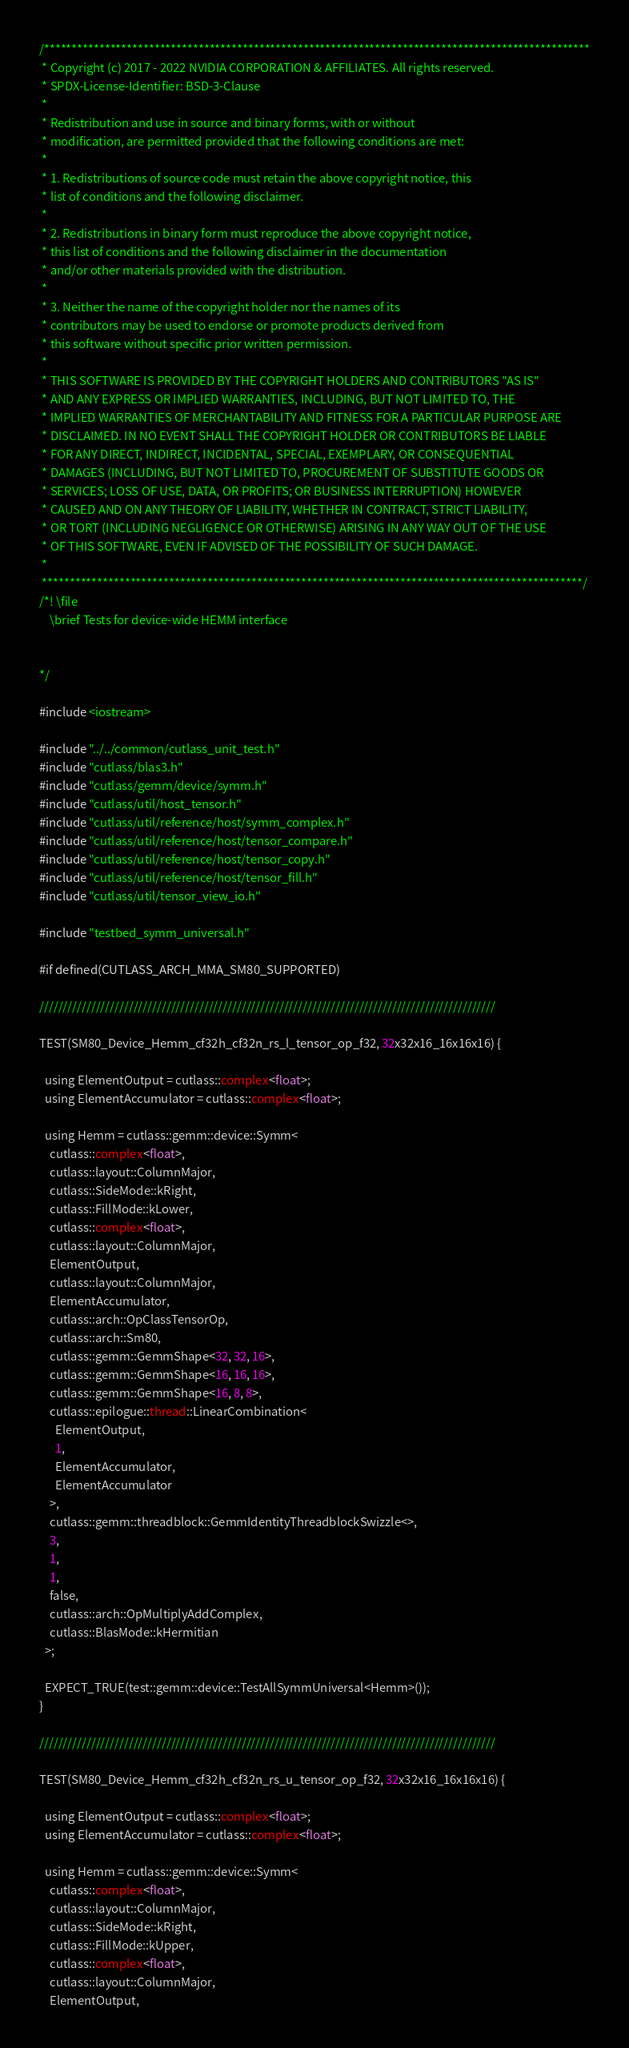Convert code to text. <code><loc_0><loc_0><loc_500><loc_500><_Cuda_>/***************************************************************************************************
 * Copyright (c) 2017 - 2022 NVIDIA CORPORATION & AFFILIATES. All rights reserved.
 * SPDX-License-Identifier: BSD-3-Clause
 *
 * Redistribution and use in source and binary forms, with or without
 * modification, are permitted provided that the following conditions are met:
 *
 * 1. Redistributions of source code must retain the above copyright notice, this
 * list of conditions and the following disclaimer.
 *
 * 2. Redistributions in binary form must reproduce the above copyright notice,
 * this list of conditions and the following disclaimer in the documentation
 * and/or other materials provided with the distribution.
 *
 * 3. Neither the name of the copyright holder nor the names of its
 * contributors may be used to endorse or promote products derived from
 * this software without specific prior written permission.
 *
 * THIS SOFTWARE IS PROVIDED BY THE COPYRIGHT HOLDERS AND CONTRIBUTORS "AS IS"
 * AND ANY EXPRESS OR IMPLIED WARRANTIES, INCLUDING, BUT NOT LIMITED TO, THE
 * IMPLIED WARRANTIES OF MERCHANTABILITY AND FITNESS FOR A PARTICULAR PURPOSE ARE
 * DISCLAIMED. IN NO EVENT SHALL THE COPYRIGHT HOLDER OR CONTRIBUTORS BE LIABLE
 * FOR ANY DIRECT, INDIRECT, INCIDENTAL, SPECIAL, EXEMPLARY, OR CONSEQUENTIAL
 * DAMAGES (INCLUDING, BUT NOT LIMITED TO, PROCUREMENT OF SUBSTITUTE GOODS OR
 * SERVICES; LOSS OF USE, DATA, OR PROFITS; OR BUSINESS INTERRUPTION) HOWEVER
 * CAUSED AND ON ANY THEORY OF LIABILITY, WHETHER IN CONTRACT, STRICT LIABILITY,
 * OR TORT (INCLUDING NEGLIGENCE OR OTHERWISE) ARISING IN ANY WAY OUT OF THE USE
 * OF THIS SOFTWARE, EVEN IF ADVISED OF THE POSSIBILITY OF SUCH DAMAGE.
 *
 **************************************************************************************************/
/*! \file
    \brief Tests for device-wide HEMM interface

  
*/

#include <iostream>

#include "../../common/cutlass_unit_test.h"
#include "cutlass/blas3.h"
#include "cutlass/gemm/device/symm.h"
#include "cutlass/util/host_tensor.h"
#include "cutlass/util/reference/host/symm_complex.h"
#include "cutlass/util/reference/host/tensor_compare.h"
#include "cutlass/util/reference/host/tensor_copy.h"
#include "cutlass/util/reference/host/tensor_fill.h"
#include "cutlass/util/tensor_view_io.h"

#include "testbed_symm_universal.h"

#if defined(CUTLASS_ARCH_MMA_SM80_SUPPORTED)

/////////////////////////////////////////////////////////////////////////////////////////////////

TEST(SM80_Device_Hemm_cf32h_cf32n_rs_l_tensor_op_f32, 32x32x16_16x16x16) {

  using ElementOutput = cutlass::complex<float>;
  using ElementAccumulator = cutlass::complex<float>;

  using Hemm = cutlass::gemm::device::Symm<
    cutlass::complex<float>,
    cutlass::layout::ColumnMajor,
    cutlass::SideMode::kRight,
    cutlass::FillMode::kLower,
    cutlass::complex<float>,
    cutlass::layout::ColumnMajor,
    ElementOutput,
    cutlass::layout::ColumnMajor,
    ElementAccumulator,
    cutlass::arch::OpClassTensorOp,
    cutlass::arch::Sm80,
    cutlass::gemm::GemmShape<32, 32, 16>,
    cutlass::gemm::GemmShape<16, 16, 16>,
    cutlass::gemm::GemmShape<16, 8, 8>,
    cutlass::epilogue::thread::LinearCombination<
      ElementOutput,
      1,
      ElementAccumulator,
      ElementAccumulator
    >,
    cutlass::gemm::threadblock::GemmIdentityThreadblockSwizzle<>,
    3,
    1,
    1,
    false,
    cutlass::arch::OpMultiplyAddComplex,
    cutlass::BlasMode::kHermitian
  >;

  EXPECT_TRUE(test::gemm::device::TestAllSymmUniversal<Hemm>());
}

/////////////////////////////////////////////////////////////////////////////////////////////////

TEST(SM80_Device_Hemm_cf32h_cf32n_rs_u_tensor_op_f32, 32x32x16_16x16x16) {

  using ElementOutput = cutlass::complex<float>;
  using ElementAccumulator = cutlass::complex<float>;

  using Hemm = cutlass::gemm::device::Symm<
    cutlass::complex<float>,
    cutlass::layout::ColumnMajor,
    cutlass::SideMode::kRight,
    cutlass::FillMode::kUpper,
    cutlass::complex<float>,
    cutlass::layout::ColumnMajor,
    ElementOutput,</code> 